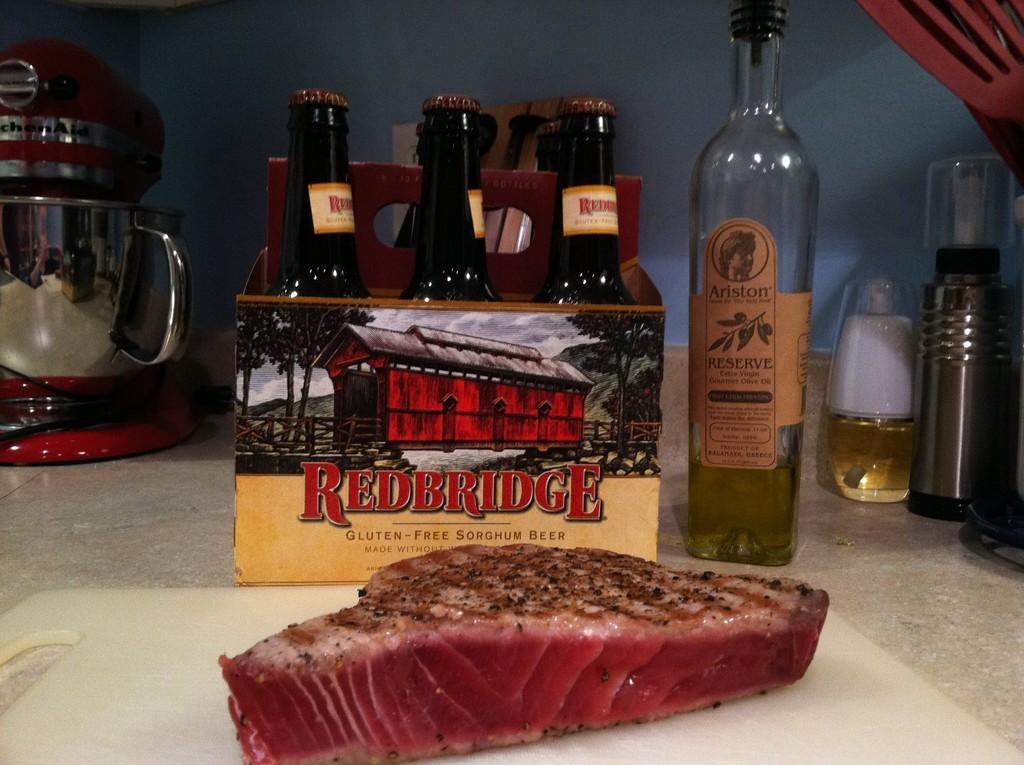<image>
Create a compact narrative representing the image presented. A chuck of steak is sitting on a cutting board by a six pack of Redbridge beer. 